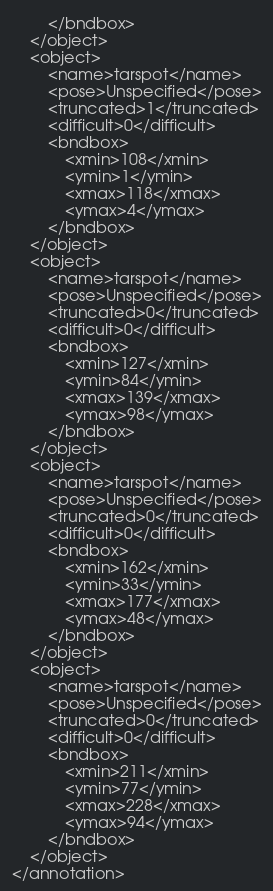Convert code to text. <code><loc_0><loc_0><loc_500><loc_500><_XML_>		</bndbox>
	</object>
	<object>
		<name>tarspot</name>
		<pose>Unspecified</pose>
		<truncated>1</truncated>
		<difficult>0</difficult>
		<bndbox>
			<xmin>108</xmin>
			<ymin>1</ymin>
			<xmax>118</xmax>
			<ymax>4</ymax>
		</bndbox>
	</object>
	<object>
		<name>tarspot</name>
		<pose>Unspecified</pose>
		<truncated>0</truncated>
		<difficult>0</difficult>
		<bndbox>
			<xmin>127</xmin>
			<ymin>84</ymin>
			<xmax>139</xmax>
			<ymax>98</ymax>
		</bndbox>
	</object>
	<object>
		<name>tarspot</name>
		<pose>Unspecified</pose>
		<truncated>0</truncated>
		<difficult>0</difficult>
		<bndbox>
			<xmin>162</xmin>
			<ymin>33</ymin>
			<xmax>177</xmax>
			<ymax>48</ymax>
		</bndbox>
	</object>
	<object>
		<name>tarspot</name>
		<pose>Unspecified</pose>
		<truncated>0</truncated>
		<difficult>0</difficult>
		<bndbox>
			<xmin>211</xmin>
			<ymin>77</ymin>
			<xmax>228</xmax>
			<ymax>94</ymax>
		</bndbox>
	</object>
</annotation>
</code> 